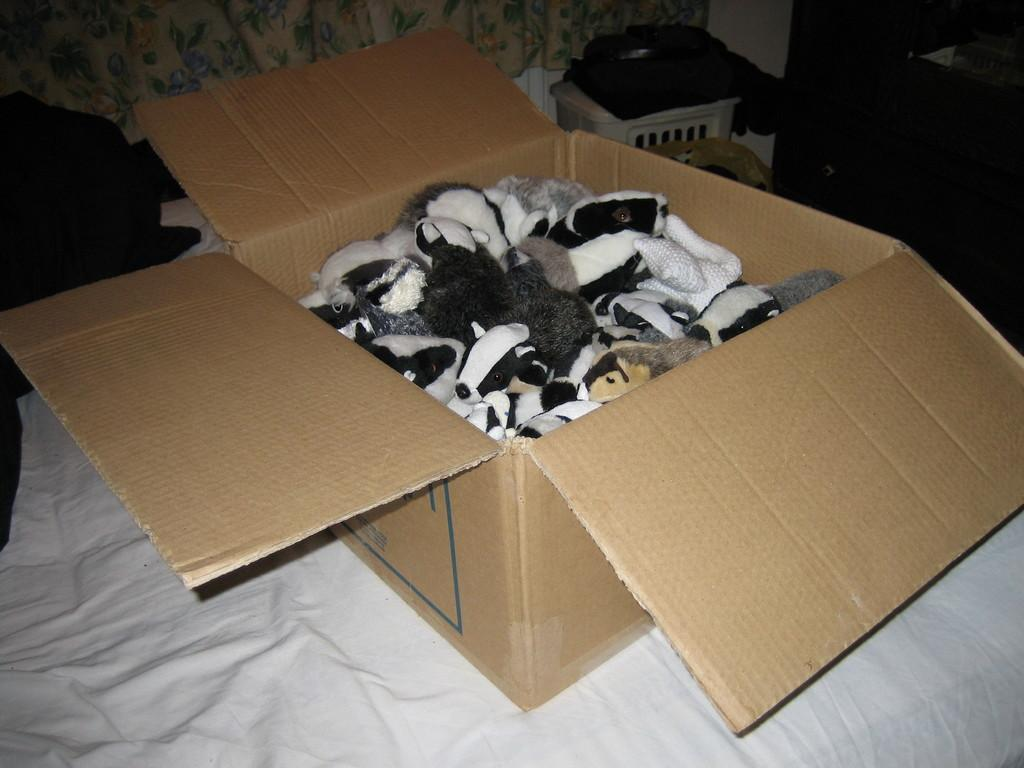What type of items can be found in the box in the image? There are toys in a box in the image. What else is present in the image besides the box of toys? There are objects and a basket in the image. What type of items can be found in the basket? The provided facts do not specify what is in the basket. What type of items can be found in the image that are not toys or objects? There are clothes in the image. How many clocks are visible in the image? There is no mention of clocks in the provided facts, so it cannot be determined how many are visible in the image. 